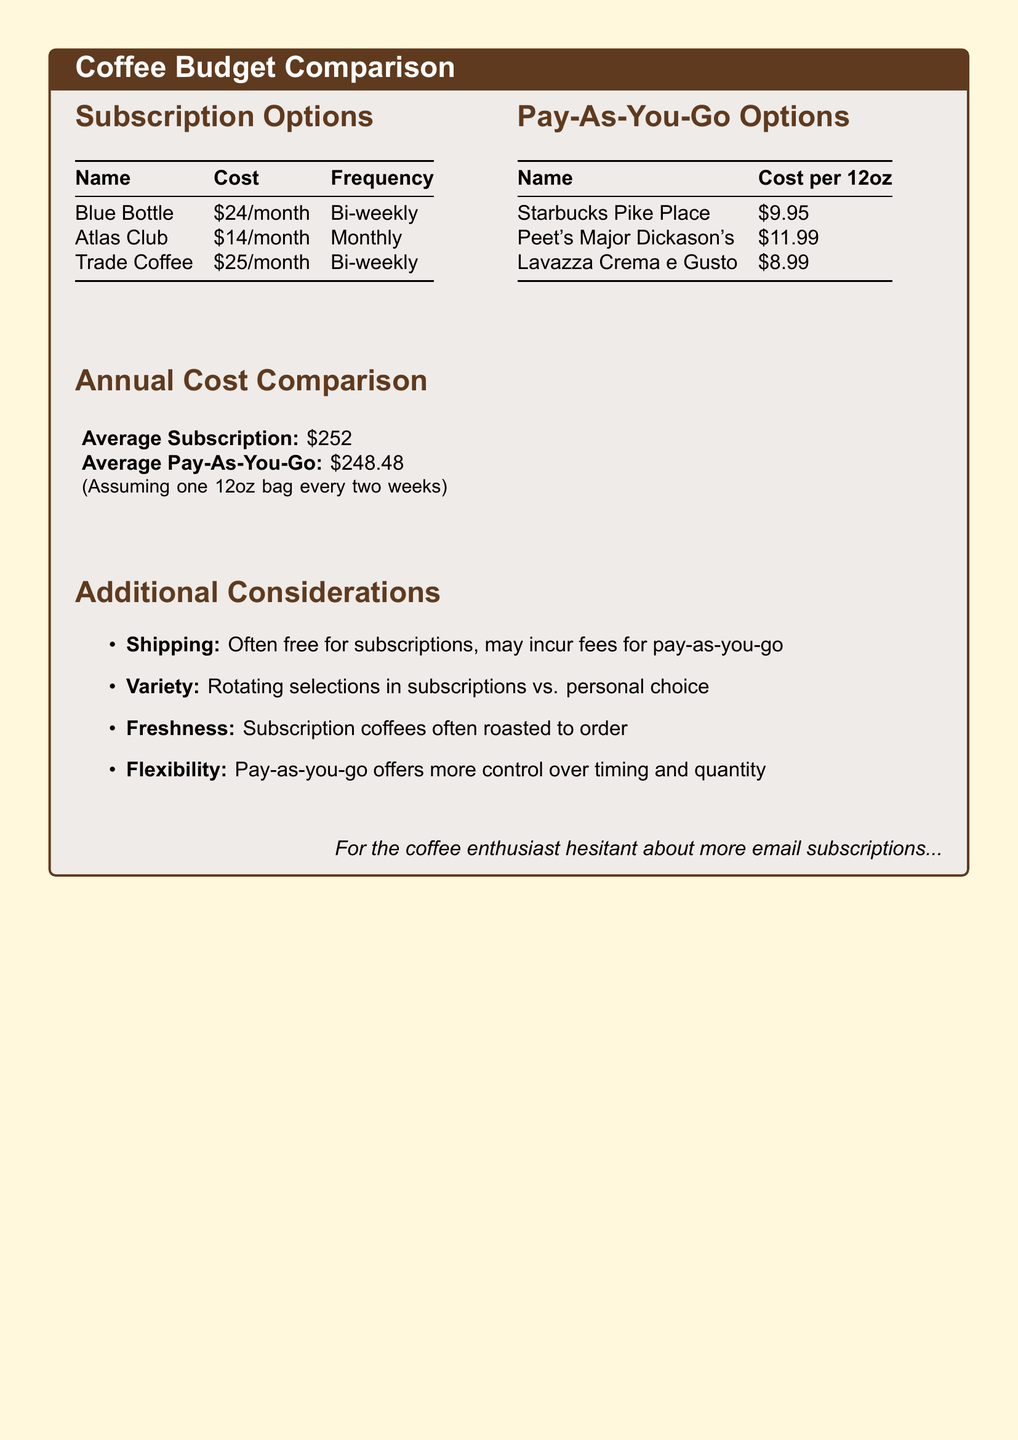What is the cost of Blue Bottle subscription? The document states that the cost of the Blue Bottle subscription is \$24/month.
Answer: \$24/month How often does the Atlas Club subscription deliver? The document indicates that the Atlas Club subscription is delivered monthly.
Answer: Monthly What is the cost of Lavazza Crema e Gusto per 12oz? According to the document, the cost for Lavazza Crema e Gusto is \$8.99 per 12oz.
Answer: \$8.99 What is the average annual cost of subscriptions? The annual cost for the average subscription is provided as \$252.
Answer: \$252 Which option has a lower annual cost on average? The document shows that the average cost of pay-as-you-go is \$248.48, which is lower than subscriptions.
Answer: Pay-As-You-Go What benefit does subscription provide regarding shipping? The document mentions that shipping is often free for subscriptions.
Answer: Free What aspect of coffee variety does the document highlight? The document notes that subscriptions offer rotating selections, while pay-as-you-go allows for personal choice.
Answer: Rotating selections What does the document suggest about coffee freshness in subscriptions? It indicates that subscription coffees are often roasted to order, emphasizing freshness.
Answer: Roasted to order What advantage does pay-as-you-go offer over subscriptions? The document states that pay-as-you-go offers more control over timing and quantity.
Answer: More control 